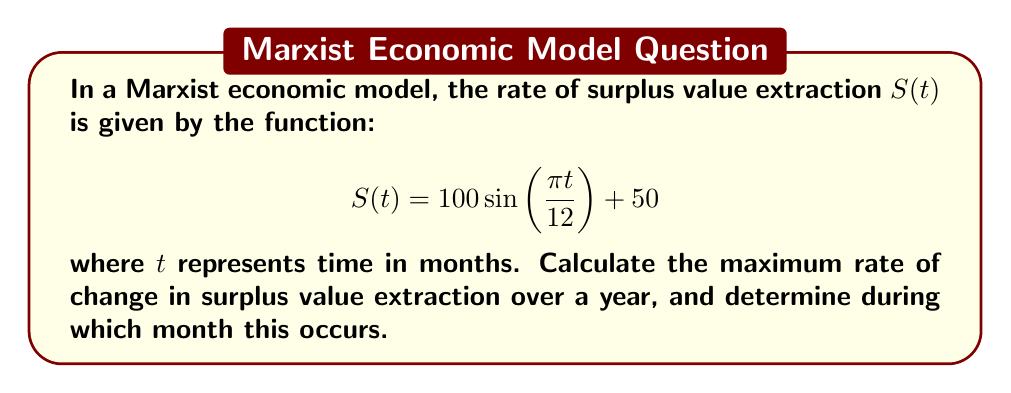Can you solve this math problem? To solve this problem, we need to follow these steps:

1) First, we need to find the derivative of $S(t)$ to get the rate of change:

   $$S'(t) = 100 \cdot \frac{\pi}{12} \cos(\frac{\pi t}{12})$$

2) To find the maximum rate of change, we need to find the maximum absolute value of $S'(t)$. The cosine function oscillates between -1 and 1, so the maximum absolute value will occur when $\cos(\frac{\pi t}{12}) = \pm 1$.

3) The maximum value of $|S'(t)|$ is:

   $$|S'(t)|_{max} = 100 \cdot \frac{\pi}{12} \approx 26.18$$

4) To determine which month this occurs, we need to solve:

   $$\cos(\frac{\pi t}{12}) = \pm 1$$

   This occurs when $\frac{\pi t}{12} = 0, \pi, 2\pi, ...$ or when $t = 0, 12, 24, ...$

5) Within a year (12 months), the maximum rate of change occurs at $t = 0$ (or 12), which corresponds to January (or December).

6) The positive maximum (increasing most rapidly) occurs at $t = 0$ (January), while the negative maximum (decreasing most rapidly) occurs at $t = 6$ (June).
Answer: 26.18 units/month, occurring in January (increasing) and June (decreasing) 